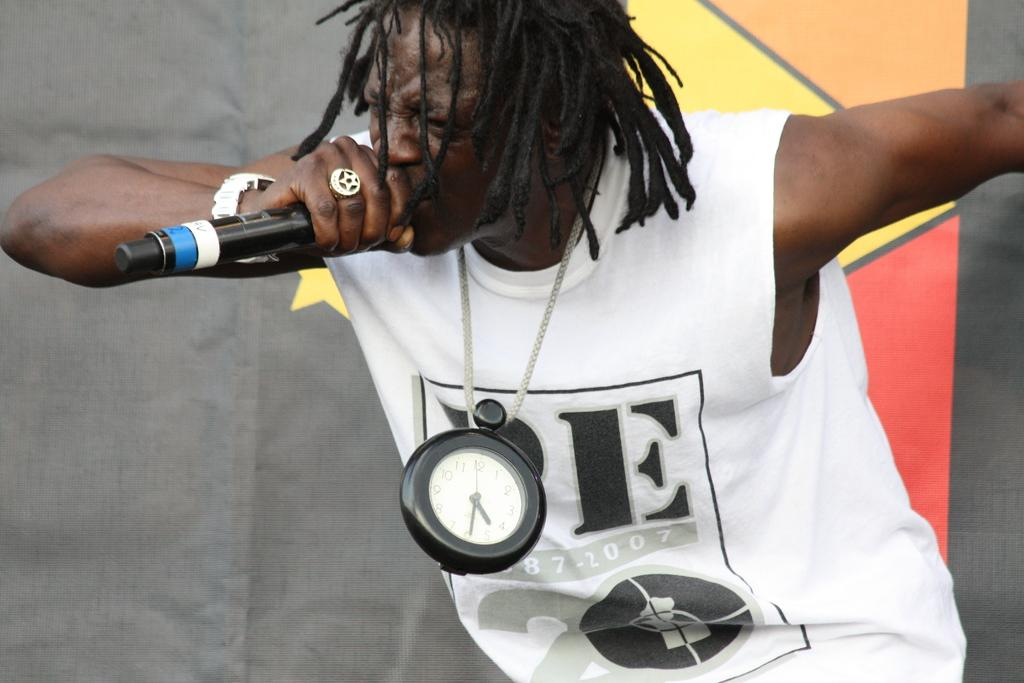<image>
Render a clear and concise summary of the photo. A performer has the year 2007 on the front of his shirt. 